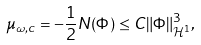<formula> <loc_0><loc_0><loc_500><loc_500>\mu _ { \omega , c } = - \frac { 1 } { 2 } N ( \Phi ) \leq C \| \Phi \| _ { \mathcal { H } ^ { 1 } } ^ { 3 } ,</formula> 